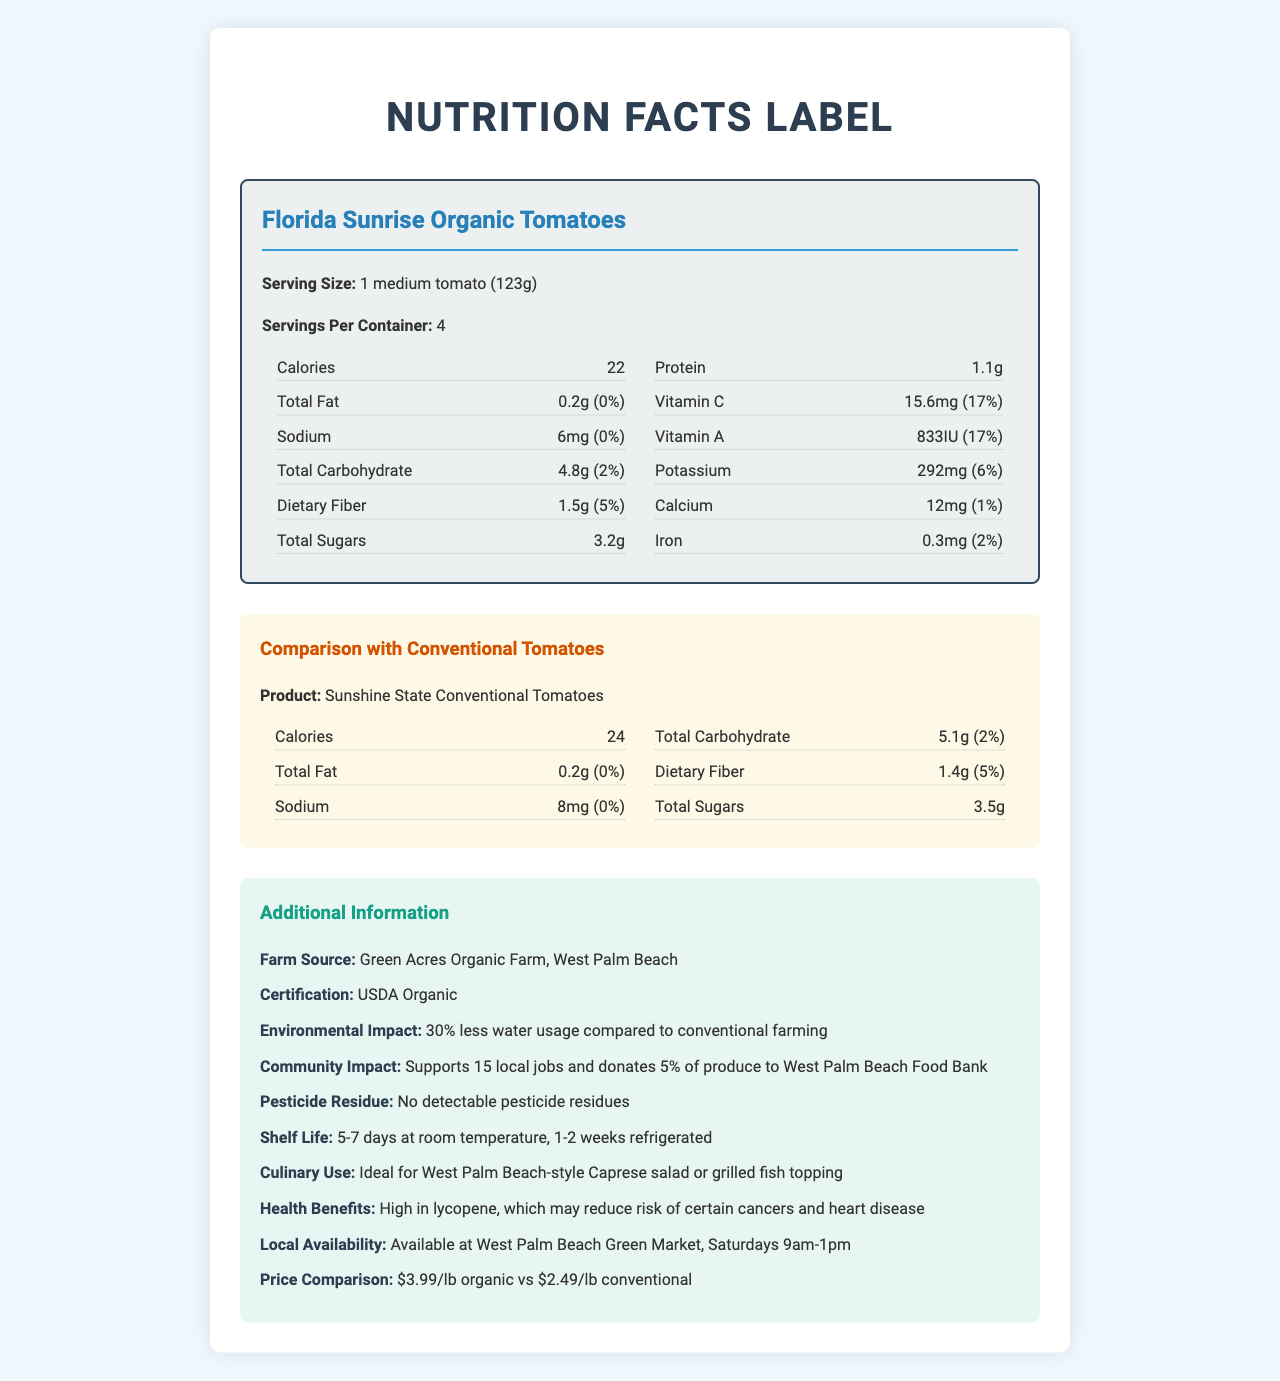what is the serving size of Florida Sunrise Organic Tomatoes? The document states that the serving size of Florida Sunrise Organic Tomatoes is 1 medium tomato (123g).
Answer: 1 medium tomato (123g) what is the farm source of the Florida Sunrise Organic Tomatoes? The additional information section mentions that the farm source is Green Acres Organic Farm, West Palm Beach.
Answer: Green Acres Organic Farm, West Palm Beach how much potassium is in one serving of Florida Sunrise Organic Tomatoes? The nutrition label shows that one serving contains 292mg of potassium, which is 6% of the daily value.
Answer: 292mg compare the vitamin A content in organic and conventional tomatoes. The nutrition facts comparison indicates that the Organic Tomatoes have 833IU of Vitamin A, while the Conventional Tomatoes have 765IU.
Answer: Florida Sunrise Organic Tomatoes: 833IU, Sunshine State Conventional Tomatoes: 765IU what is the price per pound for organic tomatoes? The price comparison in the additional information section states that organic tomatoes cost $3.99 per pound.
Answer: $3.99/lb how many local jobs are supported by buying Florida Sunrise Organic Tomatoes? The community impact section states that buying Florida Sunrise Organic Tomatoes supports 15 local jobs.
Answer: 15 local jobs what is the health benefit of Florida Sunrise Organic Tomatoes according to the document? The additional information mentions that the tomatoes are high in lycopene, which may reduce the risk of certain cancers and heart disease.
Answer: High in lycopene, which may reduce risk of certain cancers and heart disease which product has a higher calorie content per serving? A. Florida Sunrise Organic Tomatoes B. Sunshine State Conventional Tomatoes C. Both have the same calorie content The comparison section shows that organic tomatoes have 22 calories per serving, while conventional tomatoes have 24 calories per serving.
Answer: B which type of tomatoes uses less water in farming? A. Florida Sunrise Organic Tomatoes B. Sunshine State Conventional Tomatoes C. Both use the same amount of water The environmental impact section indicates that the organic tomatoes use 30% less water compared to conventional farming.
Answer: A can the pesticide residue levels of these tomatoes be compared? The document only mentions the pesticide residue for Florida Sunrise Organic Tomatoes (No detectable pesticide residues) and does not provide such information for Sunshine State Conventional Tomatoes.
Answer: No do Florida Sunrise Organic Tomatoes have a longer shelf life than conventional tomatoes? The document only provides the shelf life for Florida Sunrise Organic Tomatoes (5-7 days at room temperature, 1-2 weeks refrigerated) and does not provide shelf life information for the conventional tomatoes.
Answer: Cannot be determined are the sodium levels of the organic and conventional tomatoes the same? The organic tomatoes contain 6mg of sodium, whereas the conventional tomatoes contain 8mg of sodium according to the nutrition facts comparison.
Answer: No describe the environmental and community impacts of Florida Sunrise Organic Tomatoes. The additional information section outlines these impacts in the environmental and community impact subsections.
Answer: Florida Sunrise Organic Tomatoes use 30% less water compared to conventional farming, support 15 local jobs, and donate 5% of produce to the West Palm Beach Food Bank. summarize the main idea of the document. The document includes nutrition labels for both types of tomatoes, a comparison of their nutritional content, additional information on the benefits and impacts of Florida Sunrise Organic Tomatoes, and price differences.
Answer: The document provides detailed nutrition facts, a comparison between Florida Sunrise Organic (Green Acres Organic Farm) and Sunshine State Conventional Tomatoes, additional information on the farm source, environmental and community impacts, health benefits, culinary uses, and price comparison. 